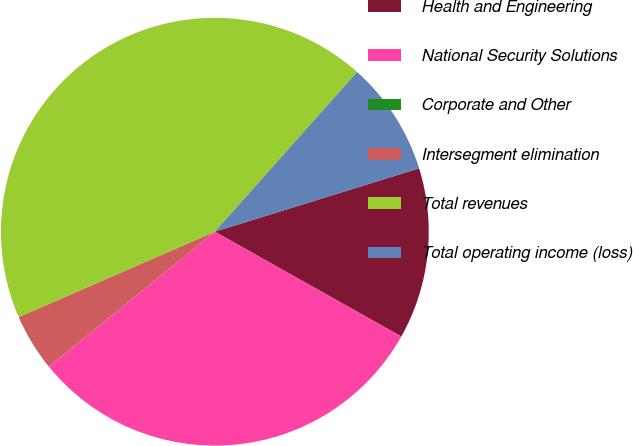Convert chart to OTSL. <chart><loc_0><loc_0><loc_500><loc_500><pie_chart><fcel>Health and Engineering<fcel>National Security Solutions<fcel>Corporate and Other<fcel>Intersegment elimination<fcel>Total revenues<fcel>Total operating income (loss)<nl><fcel>12.94%<fcel>30.99%<fcel>0.01%<fcel>4.32%<fcel>43.12%<fcel>8.63%<nl></chart> 